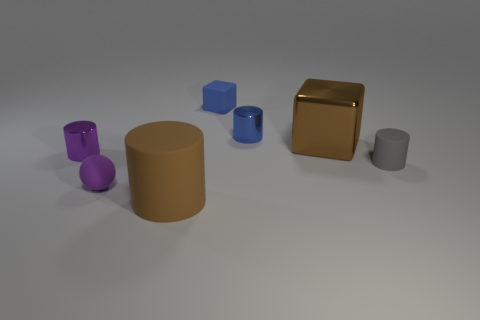Subtract 1 cylinders. How many cylinders are left? 3 Subtract all purple metallic cylinders. How many cylinders are left? 3 Subtract all gray cylinders. How many cylinders are left? 3 Add 1 large blocks. How many objects exist? 8 Subtract all blue cylinders. Subtract all gray balls. How many cylinders are left? 3 Subtract all balls. How many objects are left? 6 Add 3 tiny gray cylinders. How many tiny gray cylinders are left? 4 Add 5 tiny blue matte things. How many tiny blue matte things exist? 6 Subtract 1 brown cubes. How many objects are left? 6 Subtract all tiny red cylinders. Subtract all tiny purple objects. How many objects are left? 5 